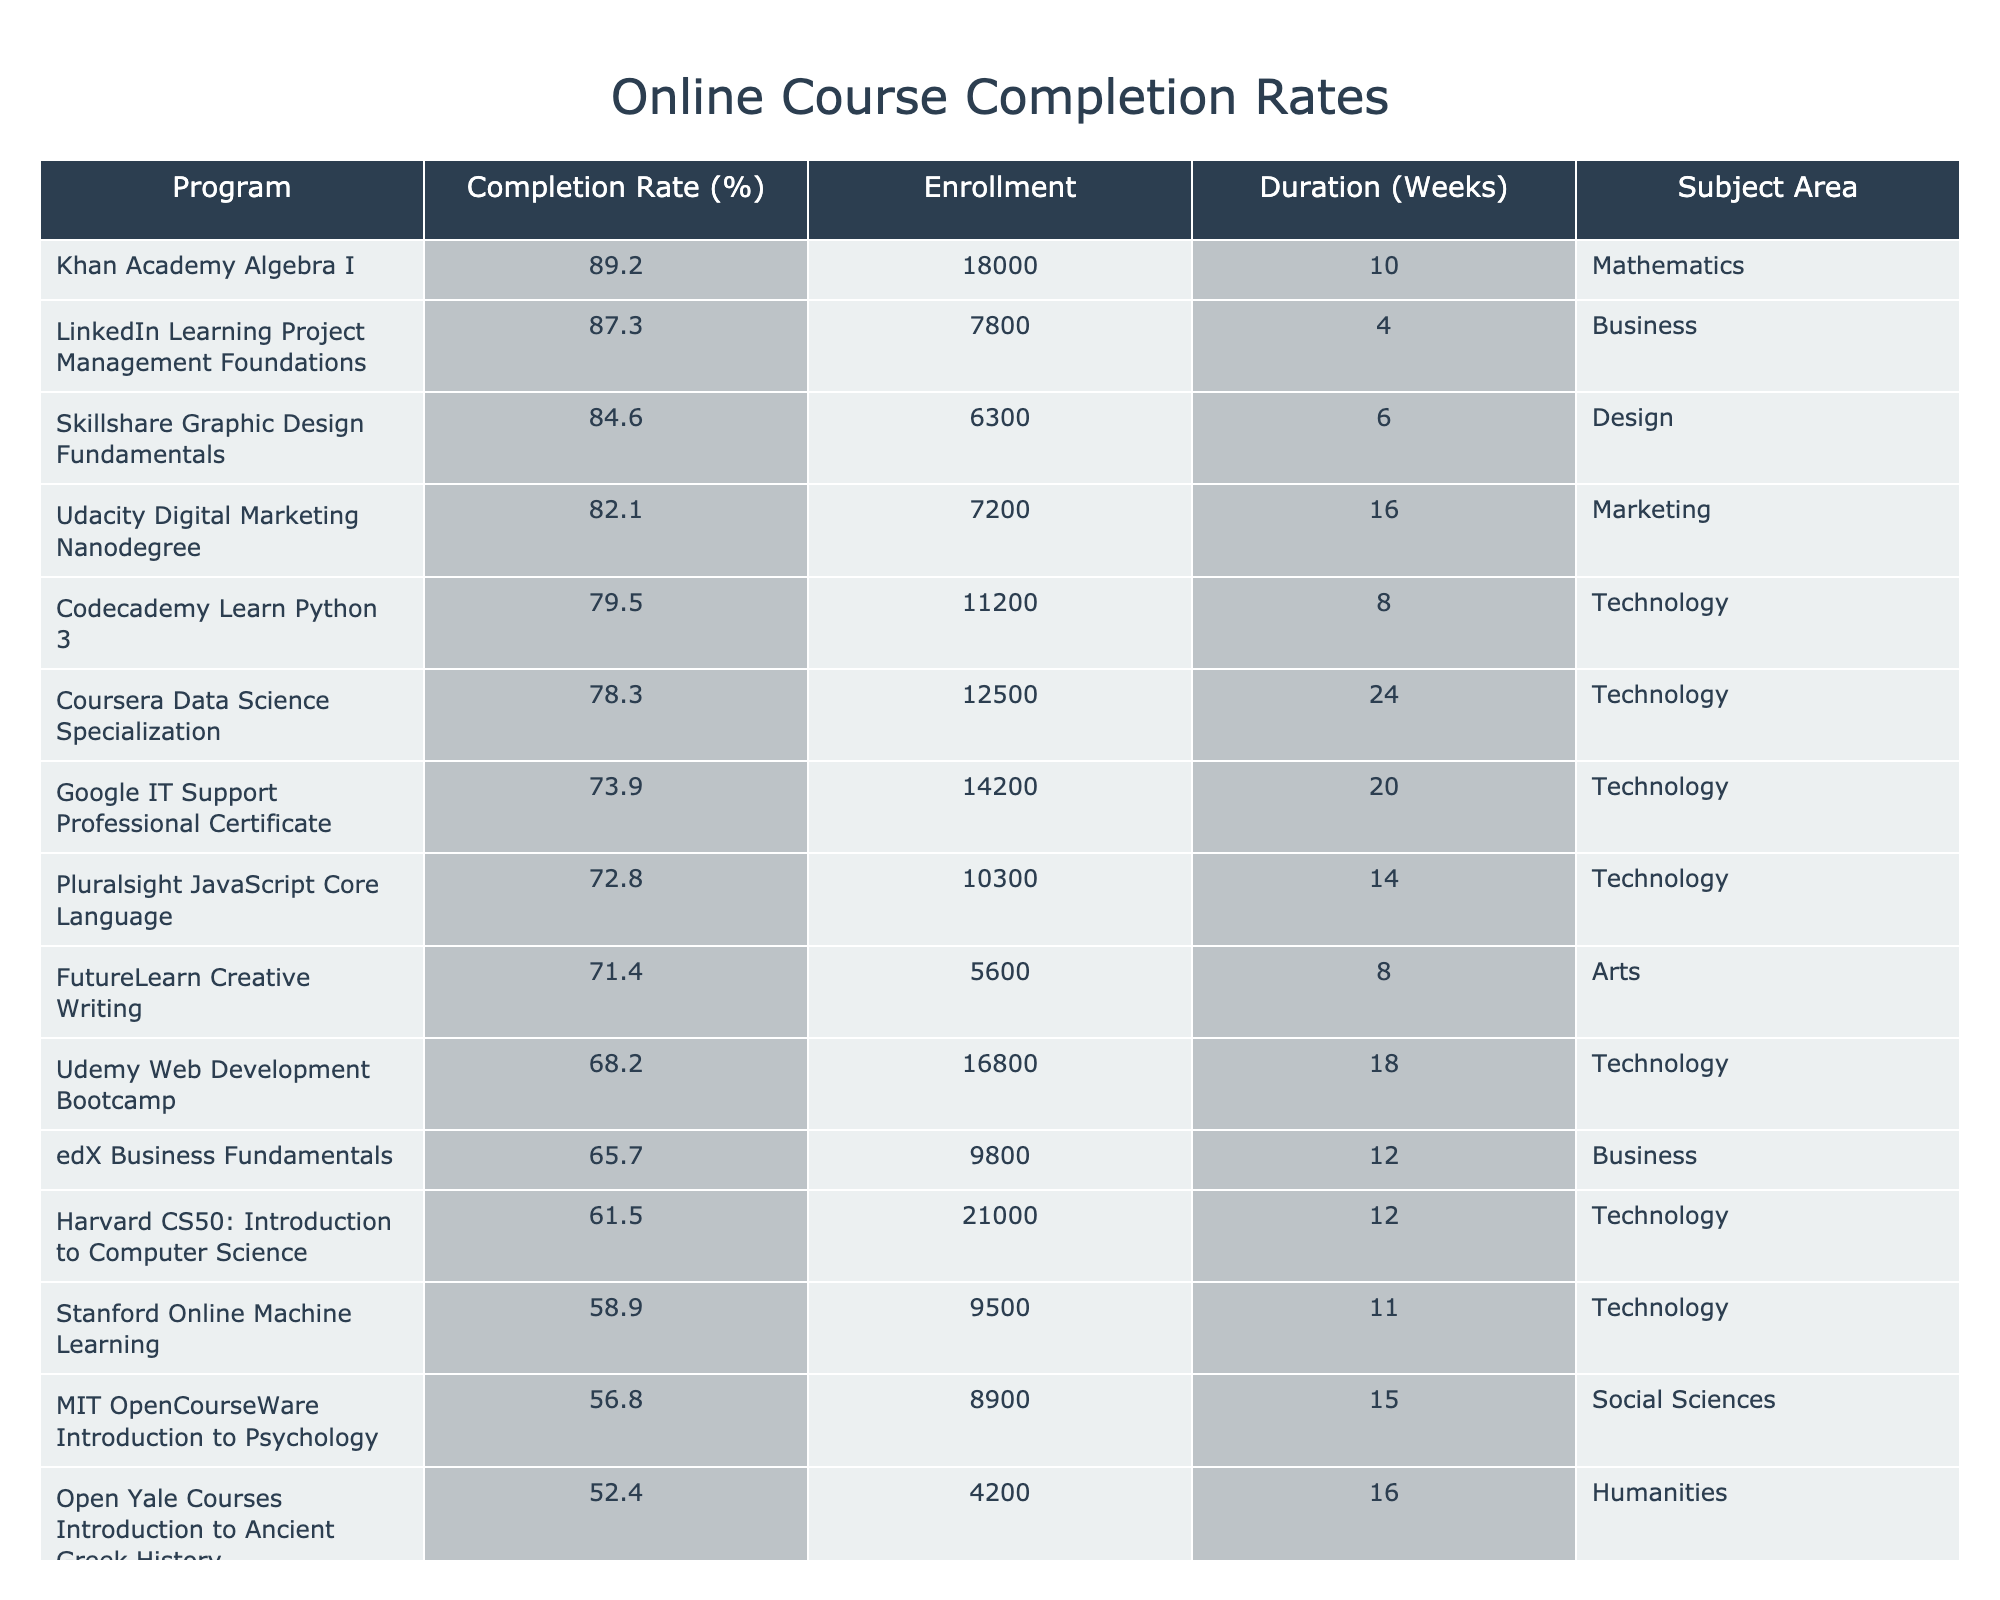What is the highest completion rate among the online programs? The highest completion rate in the table is for Khan Academy Algebra I, which is 89.2%.
Answer: 89.2% How many weeks does the Coursera Data Science Specialization last? The duration listed for the Coursera Data Science Specialization is 24 weeks.
Answer: 24 weeks Which program has the lowest completion rate? The program with the lowest completion rate is Open Yale Courses Introduction to Ancient Greek History, with a rate of 52.4%.
Answer: 52.4% What is the average completion rate of all programs listed? First, sum the completion rates of all programs (78.3 + 65.7 + 82.1 + 71.4 + 89.2 + 56.8 + 73.9 + 61.5 + 84.6 + 68.2 + 79.5 + 58.9 + 87.3 + 72.8 + 52.4) = 1096.1. There are 15 programs, so the average is 1096.1 / 15 = 73.07.
Answer: 73.07% Is the completion rate for the Udacity Digital Marketing Nanodegree higher than that for the edX Business Fundamentals program? Yes, Udacity Digital Marketing Nanodegree has a completion rate of 82.1% while edX Business Fundamentals has a completion rate of 65.7%.
Answer: Yes What is the total enrollment across all listed programs? Add up the enrollment numbers: (12500 + 9800 + 7200 + 5600 + 18000 + 8900 + 14200 + 21000 + 6300 + 16800 + 11200 + 9500 + 7800 + 10300 + 4200) = 137,600.
Answer: 137,600 Does the program with the highest enrollment also have the highest completion rate? No, Khan Academy Algebra I has the highest completion rate (89.2%) but not the highest enrollment. Harvard CS50 has the highest enrollment with 21,000 but a lower completion rate of 61.5%.
Answer: No What is the difference in completion rates between the Skillshare Graphic Design Fundamentals and the Stanford Online Machine Learning program? Skillshare has a completion rate of 84.6% and Stanford has a completion rate of 58.9%. The difference is 84.6 - 58.9 = 25.7%.
Answer: 25.7% Which subject area has the highest average completion rate? Calculate the average completion rate for each subject area: For Technology: (78.3 + 73.9 + 61.5 + 68.2 + 79.5 + 58.9) = 420.3 (total enrollment = 12500 + 14200 + 21000 + 16800 + 11200 + 9500) = 87600, average = 420.3 / 6 = 70.05%. For Business: (65.7 + 87.3) / 2 = 76.5%. For Arts: (71.4) = 71.4%. For Mathematics: (89.2) = 89.2%. For Social Sciences: (56.8) = 56.8%. For Design: (84.6) = 84.6%. For Humanities: (52.4) = 52.4%. The highest average is for Mathematics.
Answer: Mathematics Which program has a completion rate at least 80% and lasts less than 10 weeks? Skillshare Graphic Design Fundamentals has a completion rate of 84.6% and lasts 6 weeks, meeting the criteria.
Answer: Skillshare Graphic Design Fundamentals 